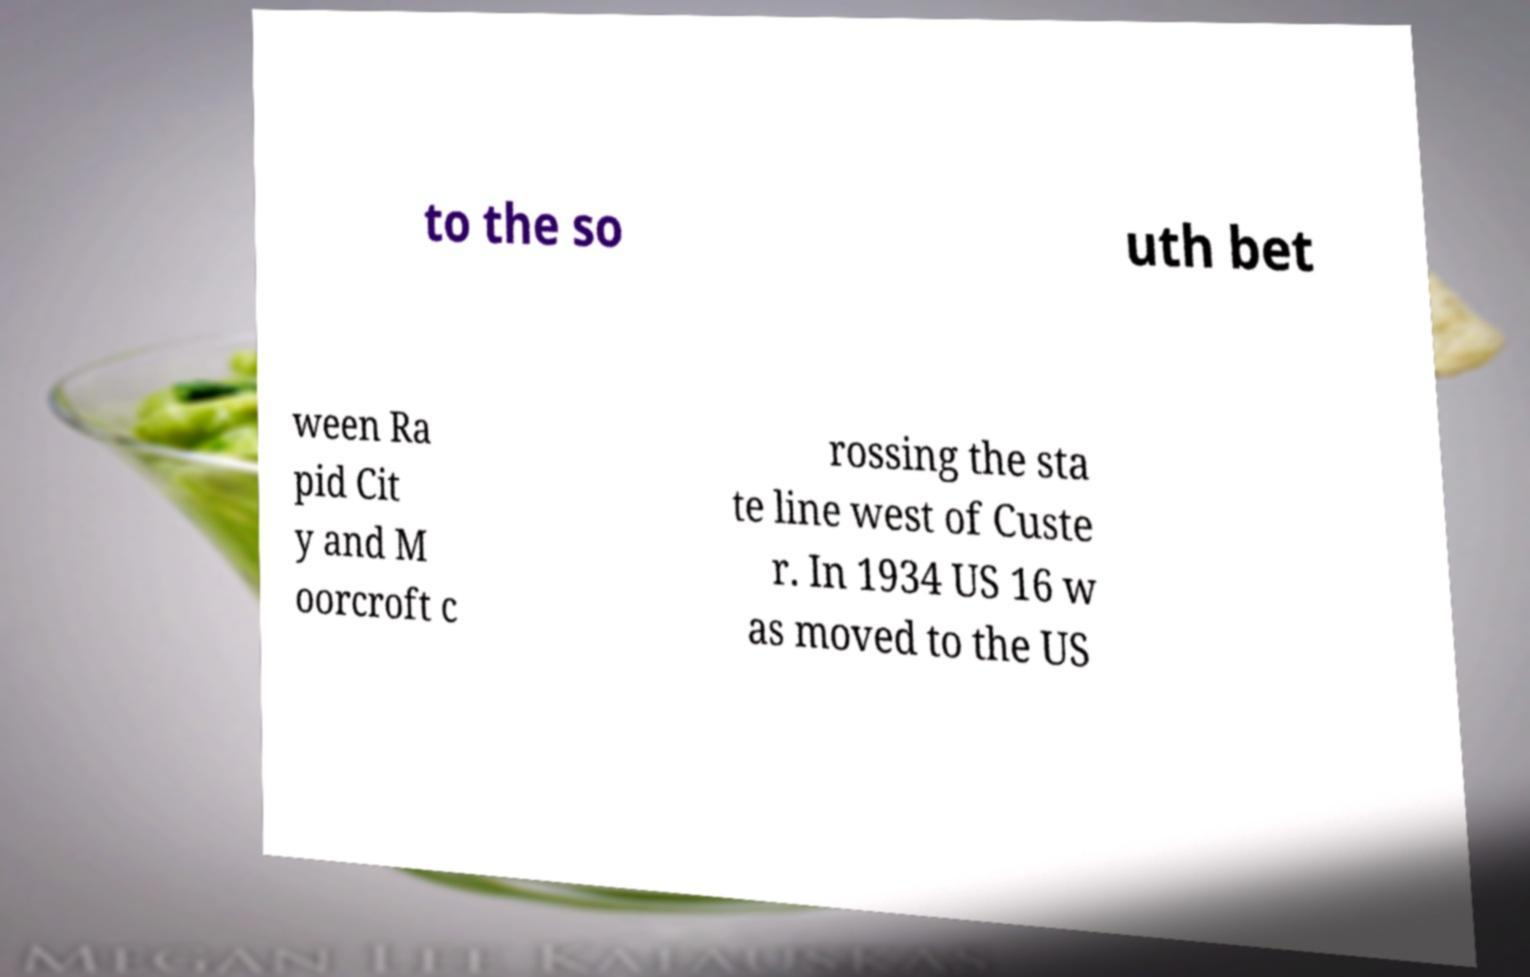Could you extract and type out the text from this image? to the so uth bet ween Ra pid Cit y and M oorcroft c rossing the sta te line west of Custe r. In 1934 US 16 w as moved to the US 